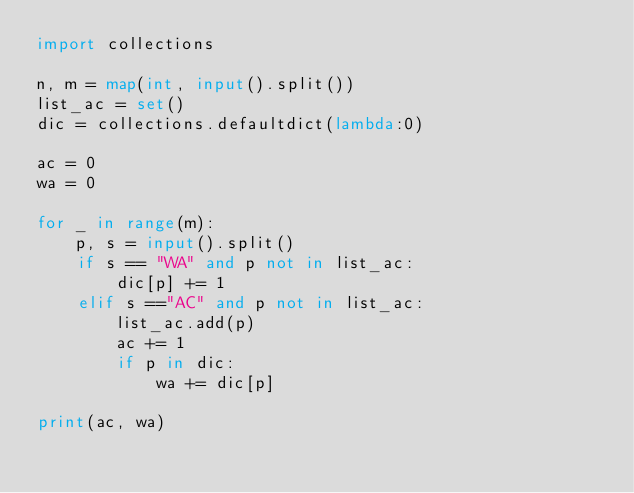<code> <loc_0><loc_0><loc_500><loc_500><_Python_>import collections

n, m = map(int, input().split())
list_ac = set()
dic = collections.defaultdict(lambda:0)

ac = 0
wa = 0

for _ in range(m):
    p, s = input().split()
    if s == "WA" and p not in list_ac:
        dic[p] += 1
    elif s =="AC" and p not in list_ac:
        list_ac.add(p)
        ac += 1
        if p in dic:
            wa += dic[p]
            
print(ac, wa)</code> 